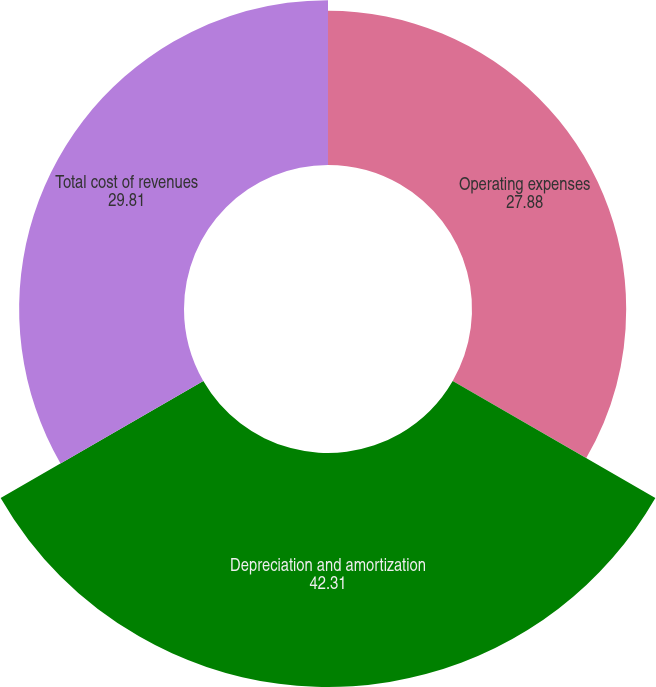<chart> <loc_0><loc_0><loc_500><loc_500><pie_chart><fcel>Operating expenses<fcel>Depreciation and amortization<fcel>Total cost of revenues<nl><fcel>27.88%<fcel>42.31%<fcel>29.81%<nl></chart> 